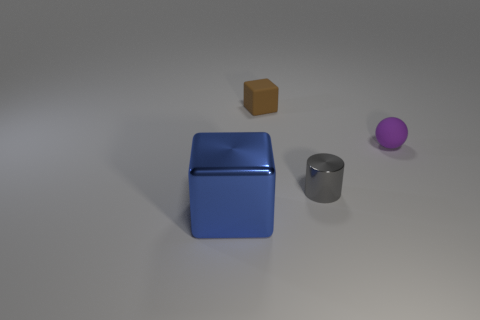There is a shiny cylinder that is the same size as the matte sphere; what color is it?
Give a very brief answer. Gray. The blue block has what size?
Your answer should be very brief. Large. Does the object that is to the left of the small brown object have the same material as the tiny purple sphere?
Offer a very short reply. No. Do the tiny brown object and the purple object have the same shape?
Keep it short and to the point. No. There is a rubber thing on the right side of the matte object that is left of the metallic thing on the right side of the large blue thing; what is its shape?
Keep it short and to the point. Sphere. There is a blue thing in front of the tiny block; does it have the same shape as the tiny thing that is to the left of the tiny gray cylinder?
Make the answer very short. Yes. Is there a cylinder that has the same material as the blue object?
Your answer should be very brief. Yes. There is a small matte object on the right side of the block behind the block on the left side of the matte block; what color is it?
Offer a terse response. Purple. Does the block on the right side of the large metallic object have the same material as the object that is on the right side of the shiny cylinder?
Ensure brevity in your answer.  Yes. There is a metallic object that is left of the tiny brown block; what shape is it?
Keep it short and to the point. Cube. 